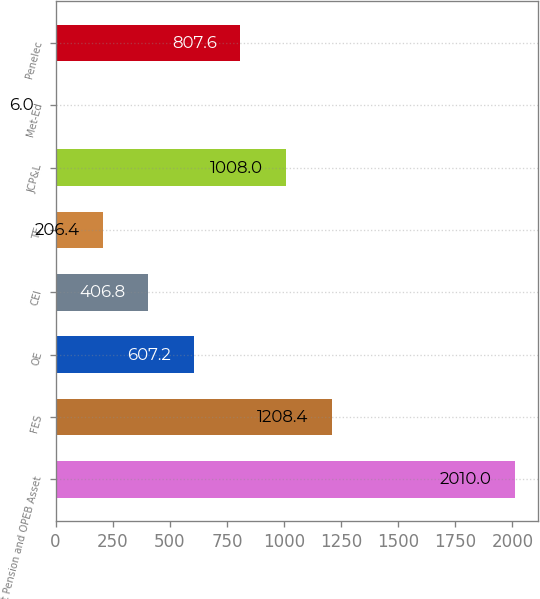Convert chart. <chart><loc_0><loc_0><loc_500><loc_500><bar_chart><fcel>Net Pension and OPEB Asset<fcel>FES<fcel>OE<fcel>CEI<fcel>TE<fcel>JCP&L<fcel>Met-Ed<fcel>Penelec<nl><fcel>2010<fcel>1208.4<fcel>607.2<fcel>406.8<fcel>206.4<fcel>1008<fcel>6<fcel>807.6<nl></chart> 